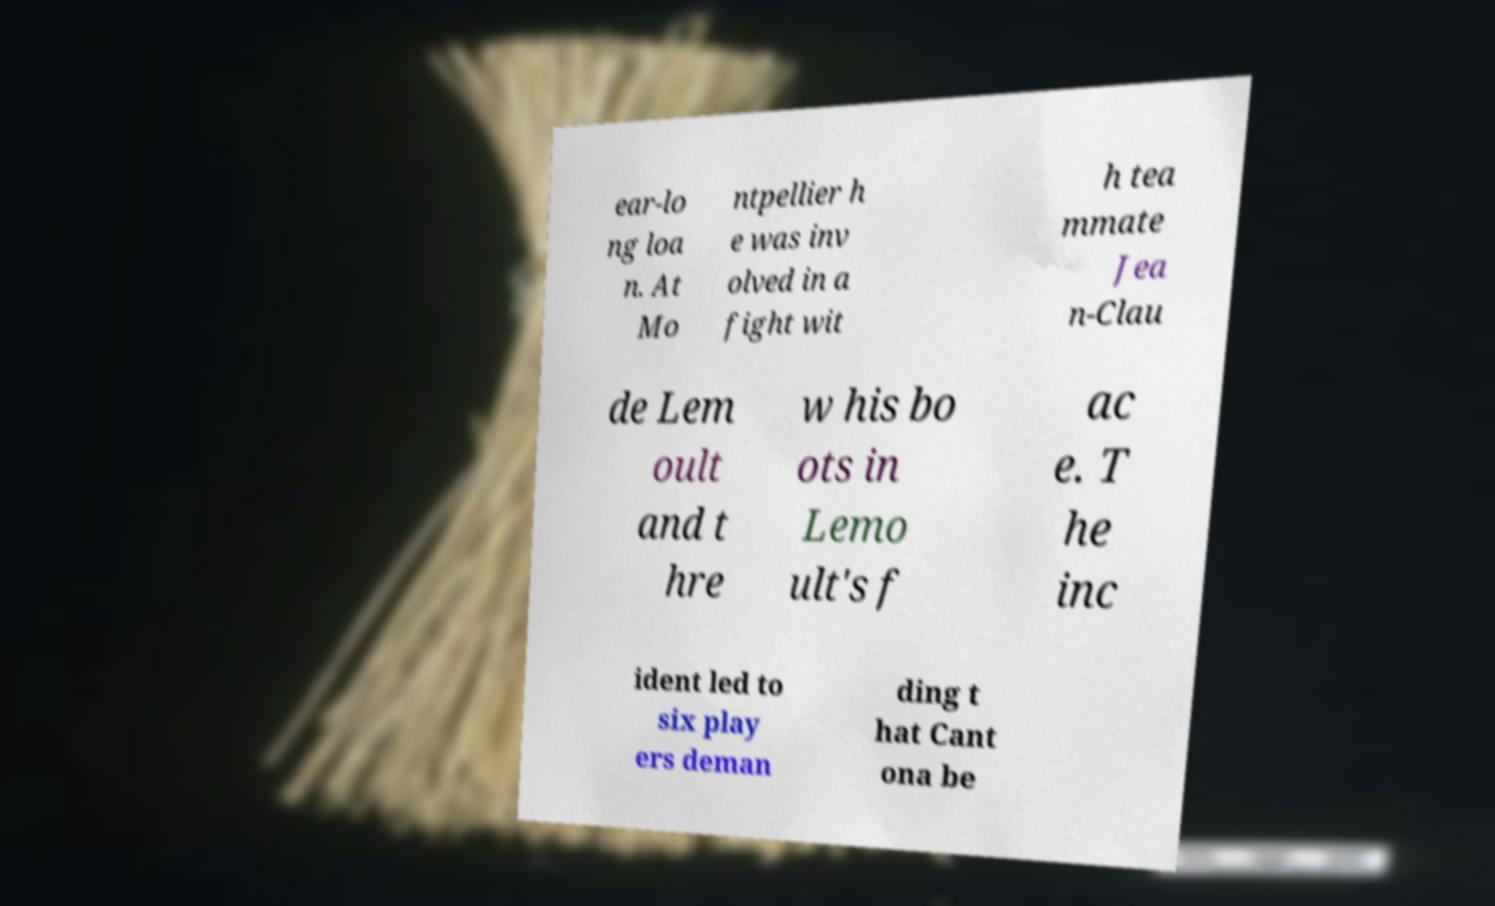I need the written content from this picture converted into text. Can you do that? ear-lo ng loa n. At Mo ntpellier h e was inv olved in a fight wit h tea mmate Jea n-Clau de Lem oult and t hre w his bo ots in Lemo ult's f ac e. T he inc ident led to six play ers deman ding t hat Cant ona be 